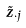<formula> <loc_0><loc_0><loc_500><loc_500>\tilde { z } _ { \cdot j }</formula> 